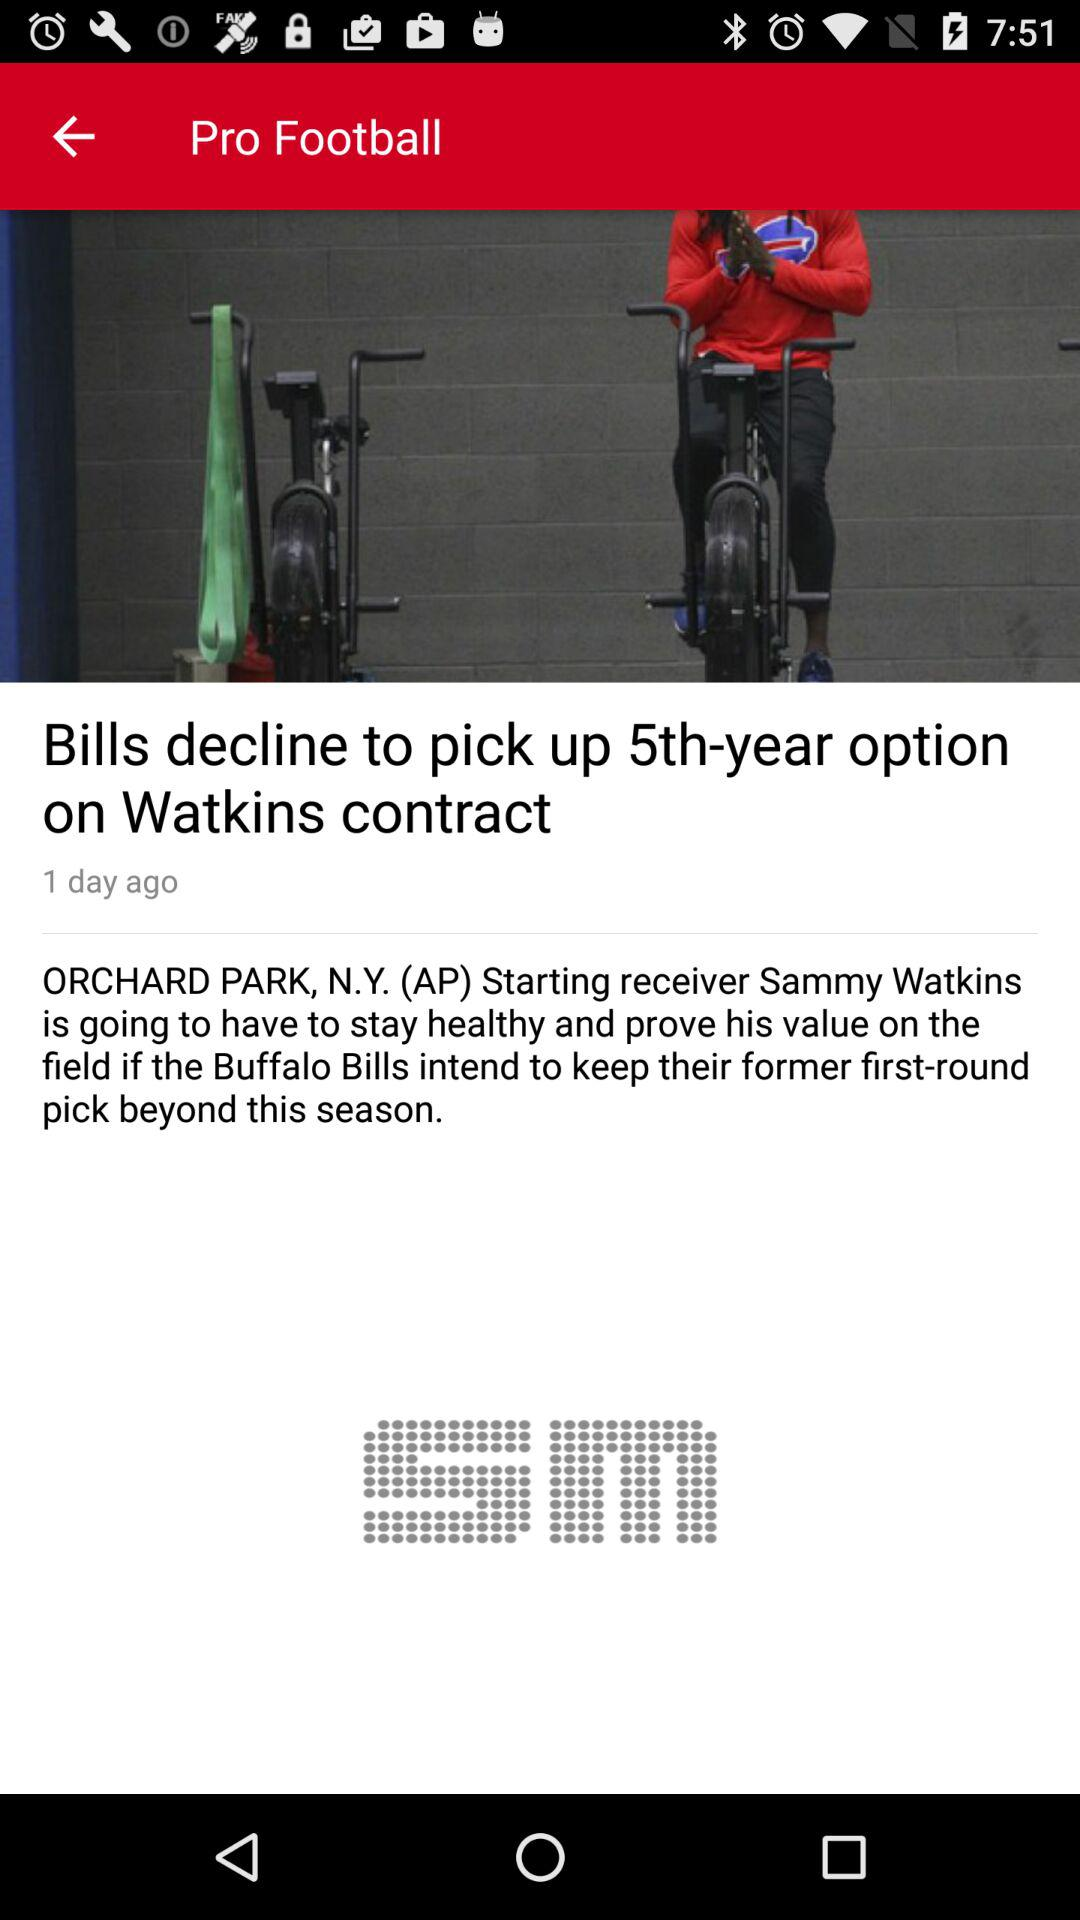When was the news "Bills decline to pick up 5th-year option on Watkins contract" posted? The news was posted 1 day ago. 